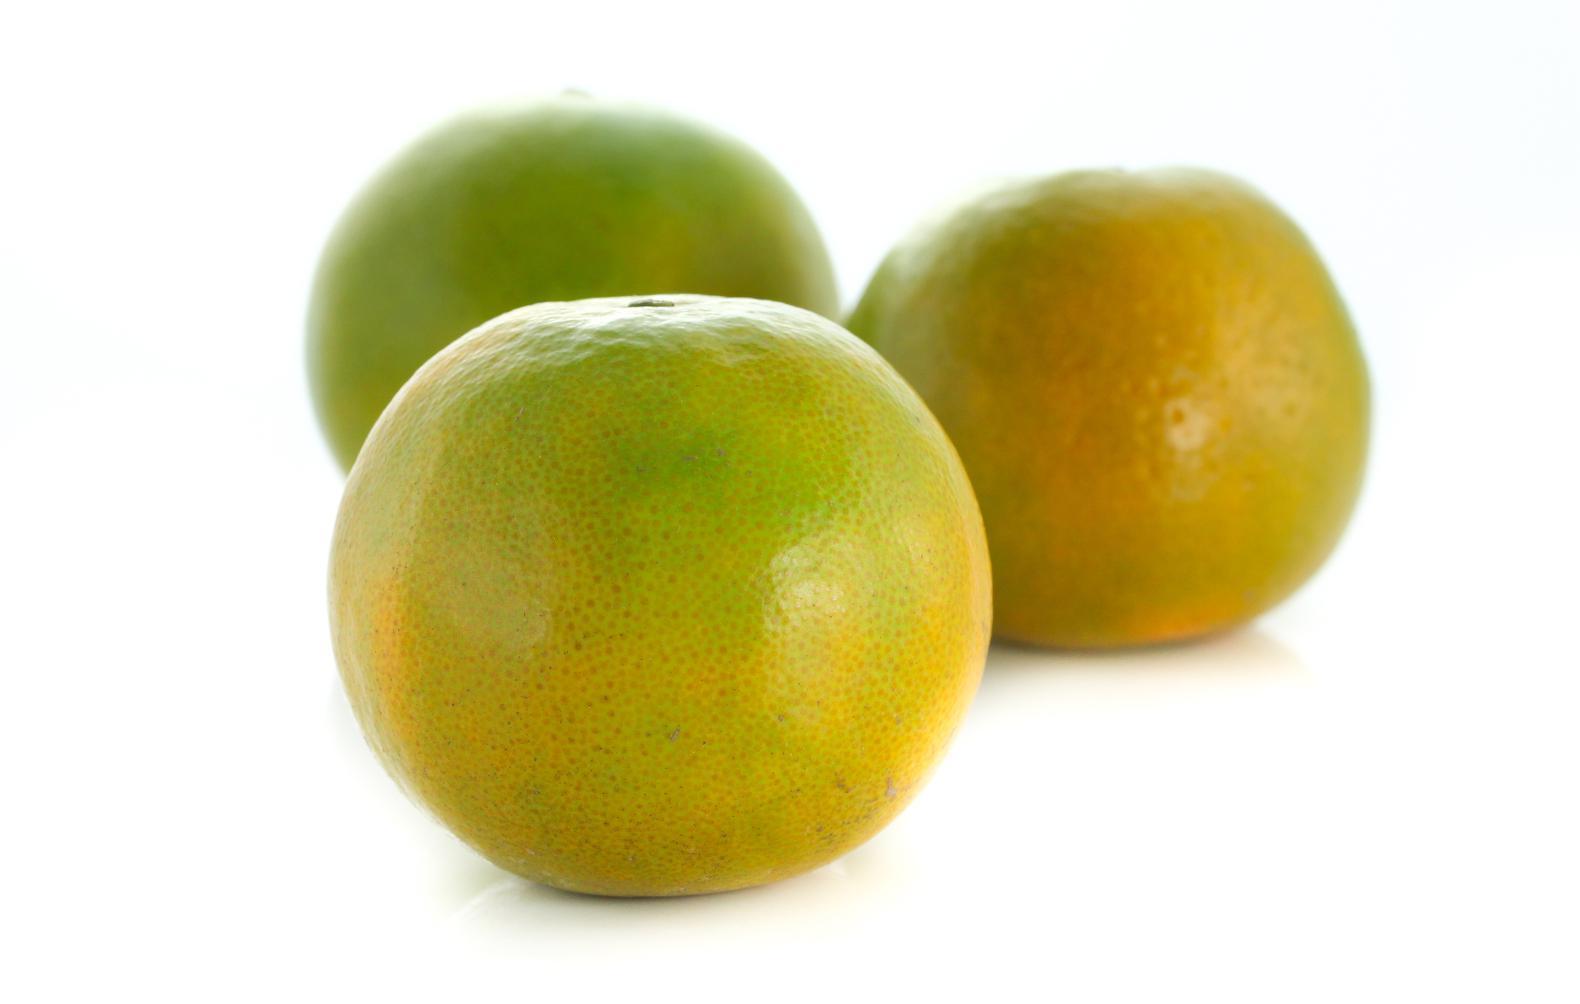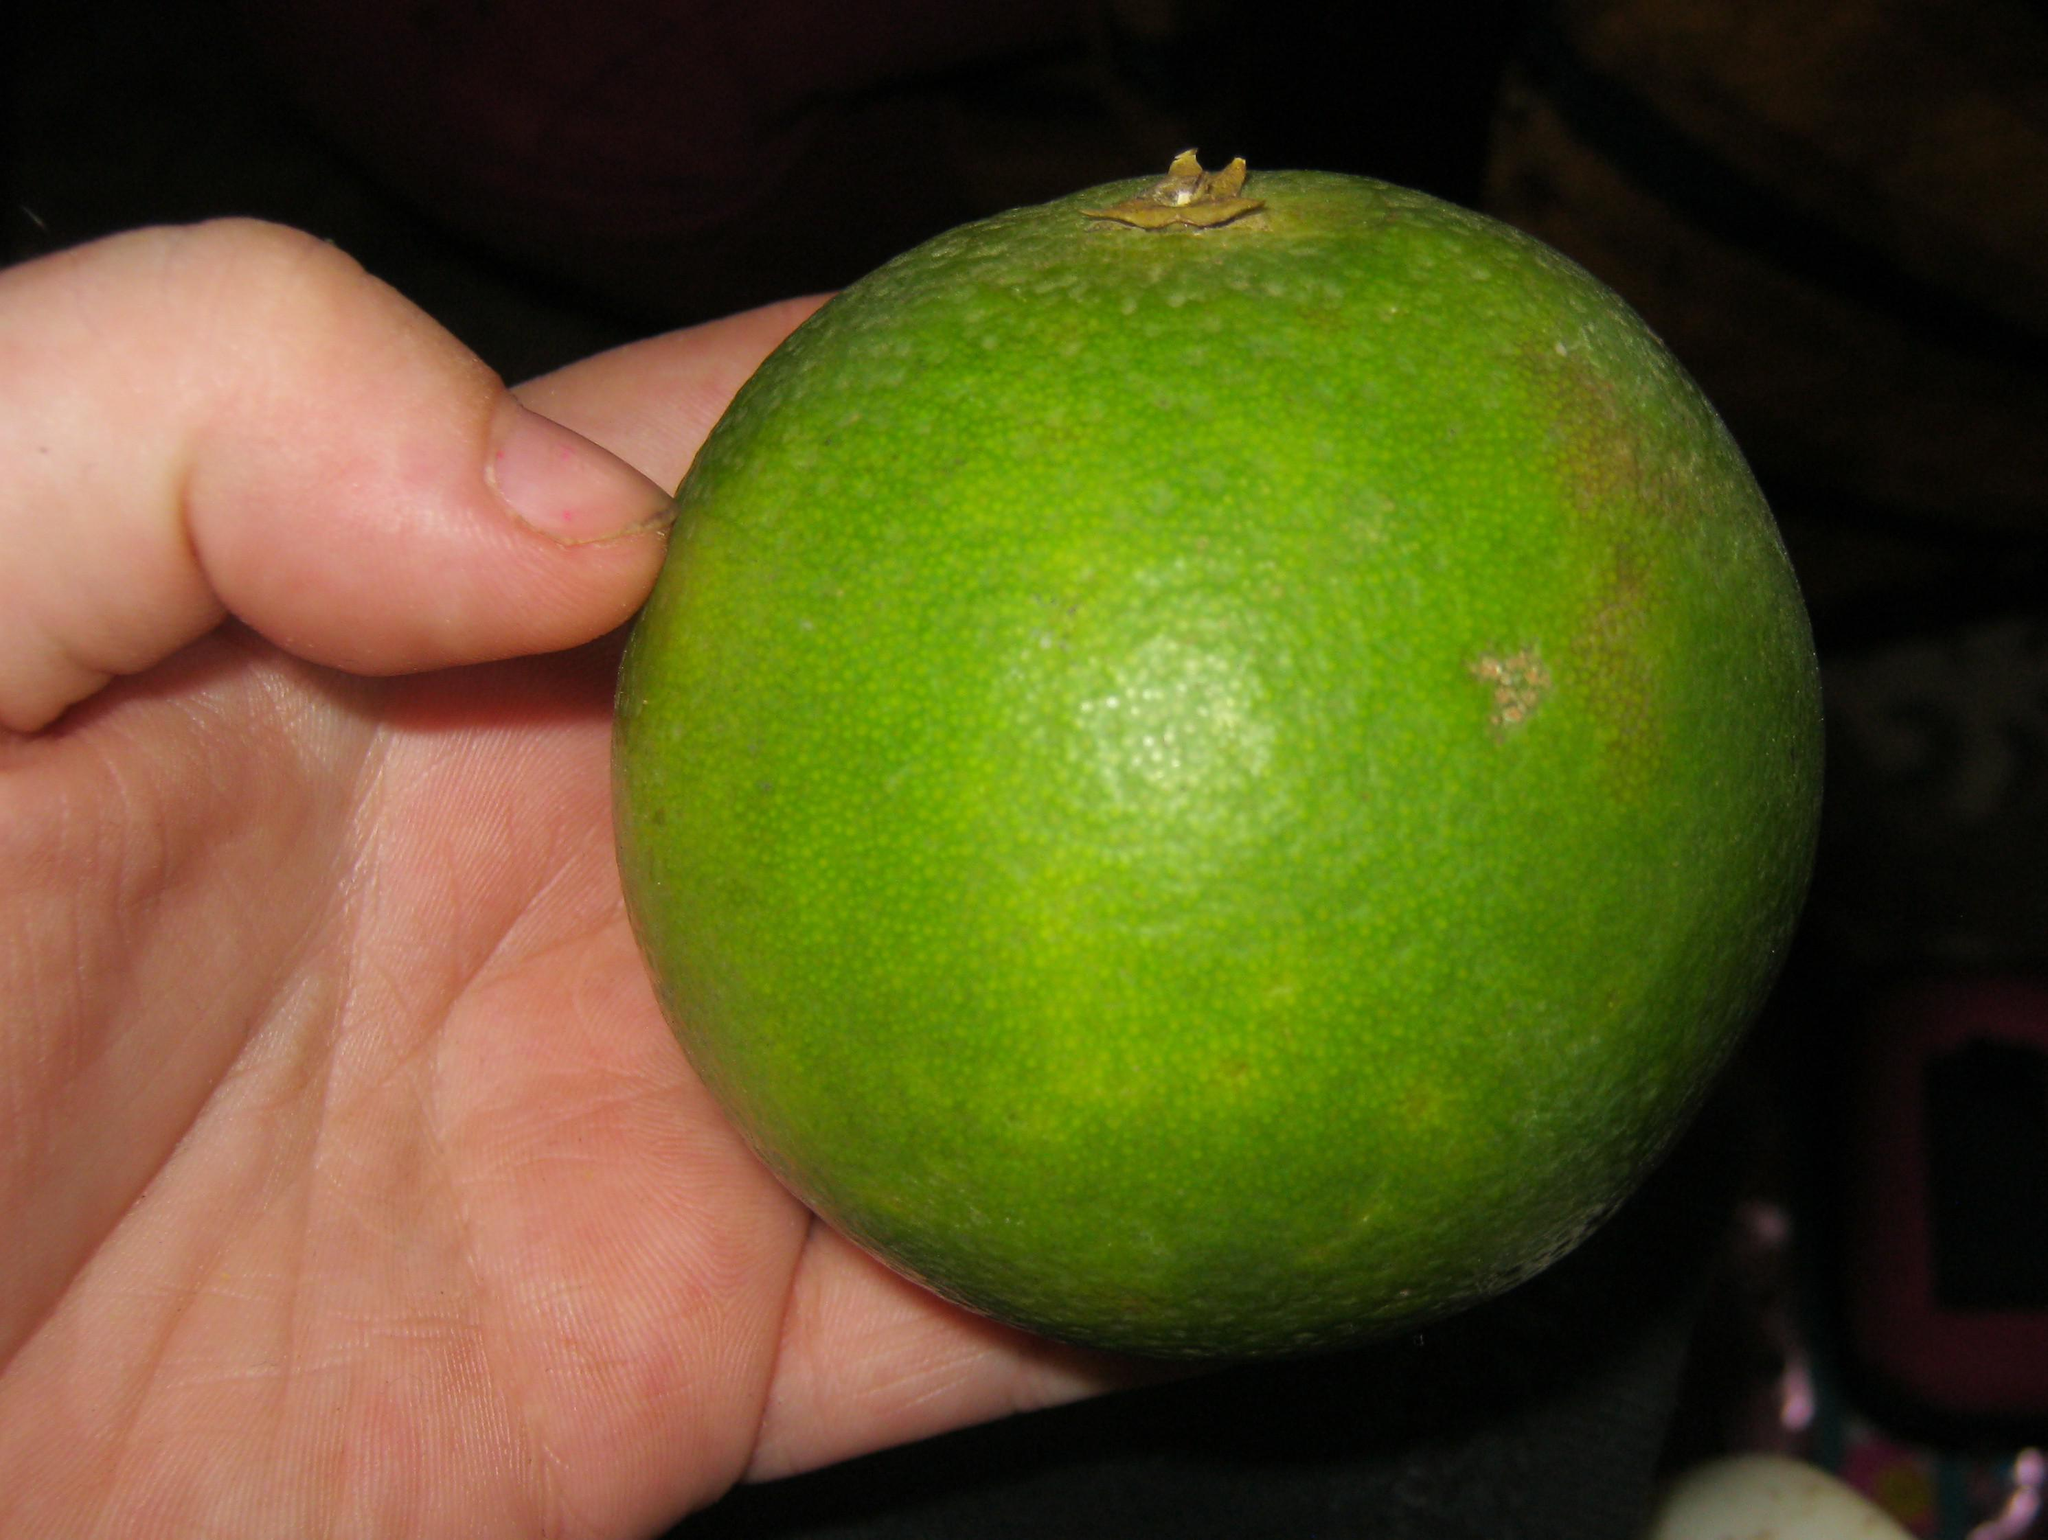The first image is the image on the left, the second image is the image on the right. Analyze the images presented: Is the assertion "There are at least 3 half mandarin fruit slices." valid? Answer yes or no. No. The first image is the image on the left, the second image is the image on the right. Analyze the images presented: Is the assertion "The fruit in only ONE of the images was cut with a knife." valid? Answer yes or no. No. 